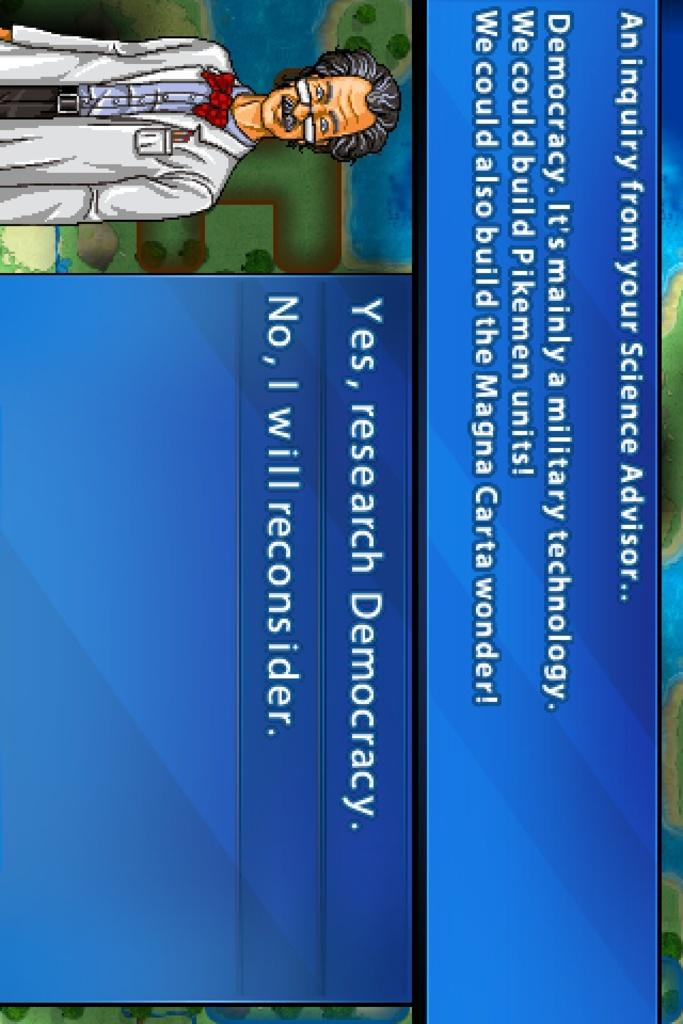<image>
Summarize the visual content of the image. An computer science advisor is asking whether the viewer wants to research Democracy. 